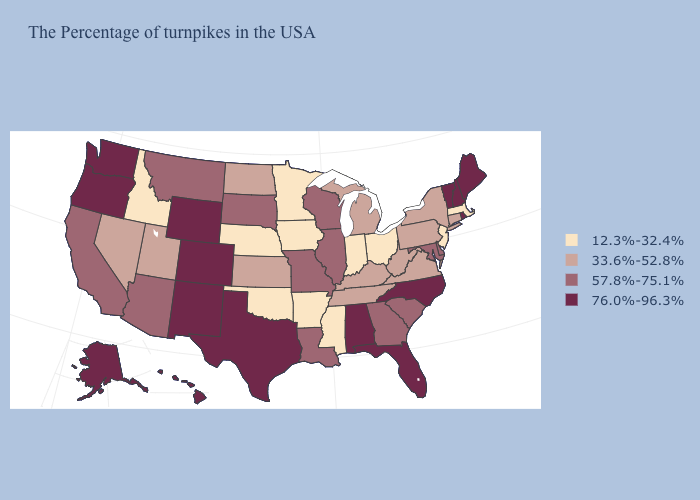What is the value of West Virginia?
Concise answer only. 33.6%-52.8%. What is the value of Massachusetts?
Answer briefly. 12.3%-32.4%. Does Massachusetts have the highest value in the Northeast?
Quick response, please. No. What is the value of Utah?
Answer briefly. 33.6%-52.8%. What is the value of Arkansas?
Write a very short answer. 12.3%-32.4%. Is the legend a continuous bar?
Give a very brief answer. No. Does Oregon have the lowest value in the West?
Short answer required. No. What is the value of Ohio?
Give a very brief answer. 12.3%-32.4%. Name the states that have a value in the range 33.6%-52.8%?
Answer briefly. Connecticut, New York, Pennsylvania, Virginia, West Virginia, Michigan, Kentucky, Tennessee, Kansas, North Dakota, Utah, Nevada. Does Alaska have the same value as Michigan?
Concise answer only. No. Does Wisconsin have a higher value than Nebraska?
Concise answer only. Yes. Name the states that have a value in the range 33.6%-52.8%?
Short answer required. Connecticut, New York, Pennsylvania, Virginia, West Virginia, Michigan, Kentucky, Tennessee, Kansas, North Dakota, Utah, Nevada. Name the states that have a value in the range 12.3%-32.4%?
Concise answer only. Massachusetts, New Jersey, Ohio, Indiana, Mississippi, Arkansas, Minnesota, Iowa, Nebraska, Oklahoma, Idaho. What is the highest value in the USA?
Short answer required. 76.0%-96.3%. Does Colorado have the highest value in the West?
Quick response, please. Yes. 